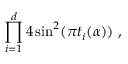Convert formula to latex. <formula><loc_0><loc_0><loc_500><loc_500>\prod _ { i = 1 } ^ { d } 4 \sin ^ { 2 } ( \pi t _ { i } ( \alpha ) ) ,</formula> 